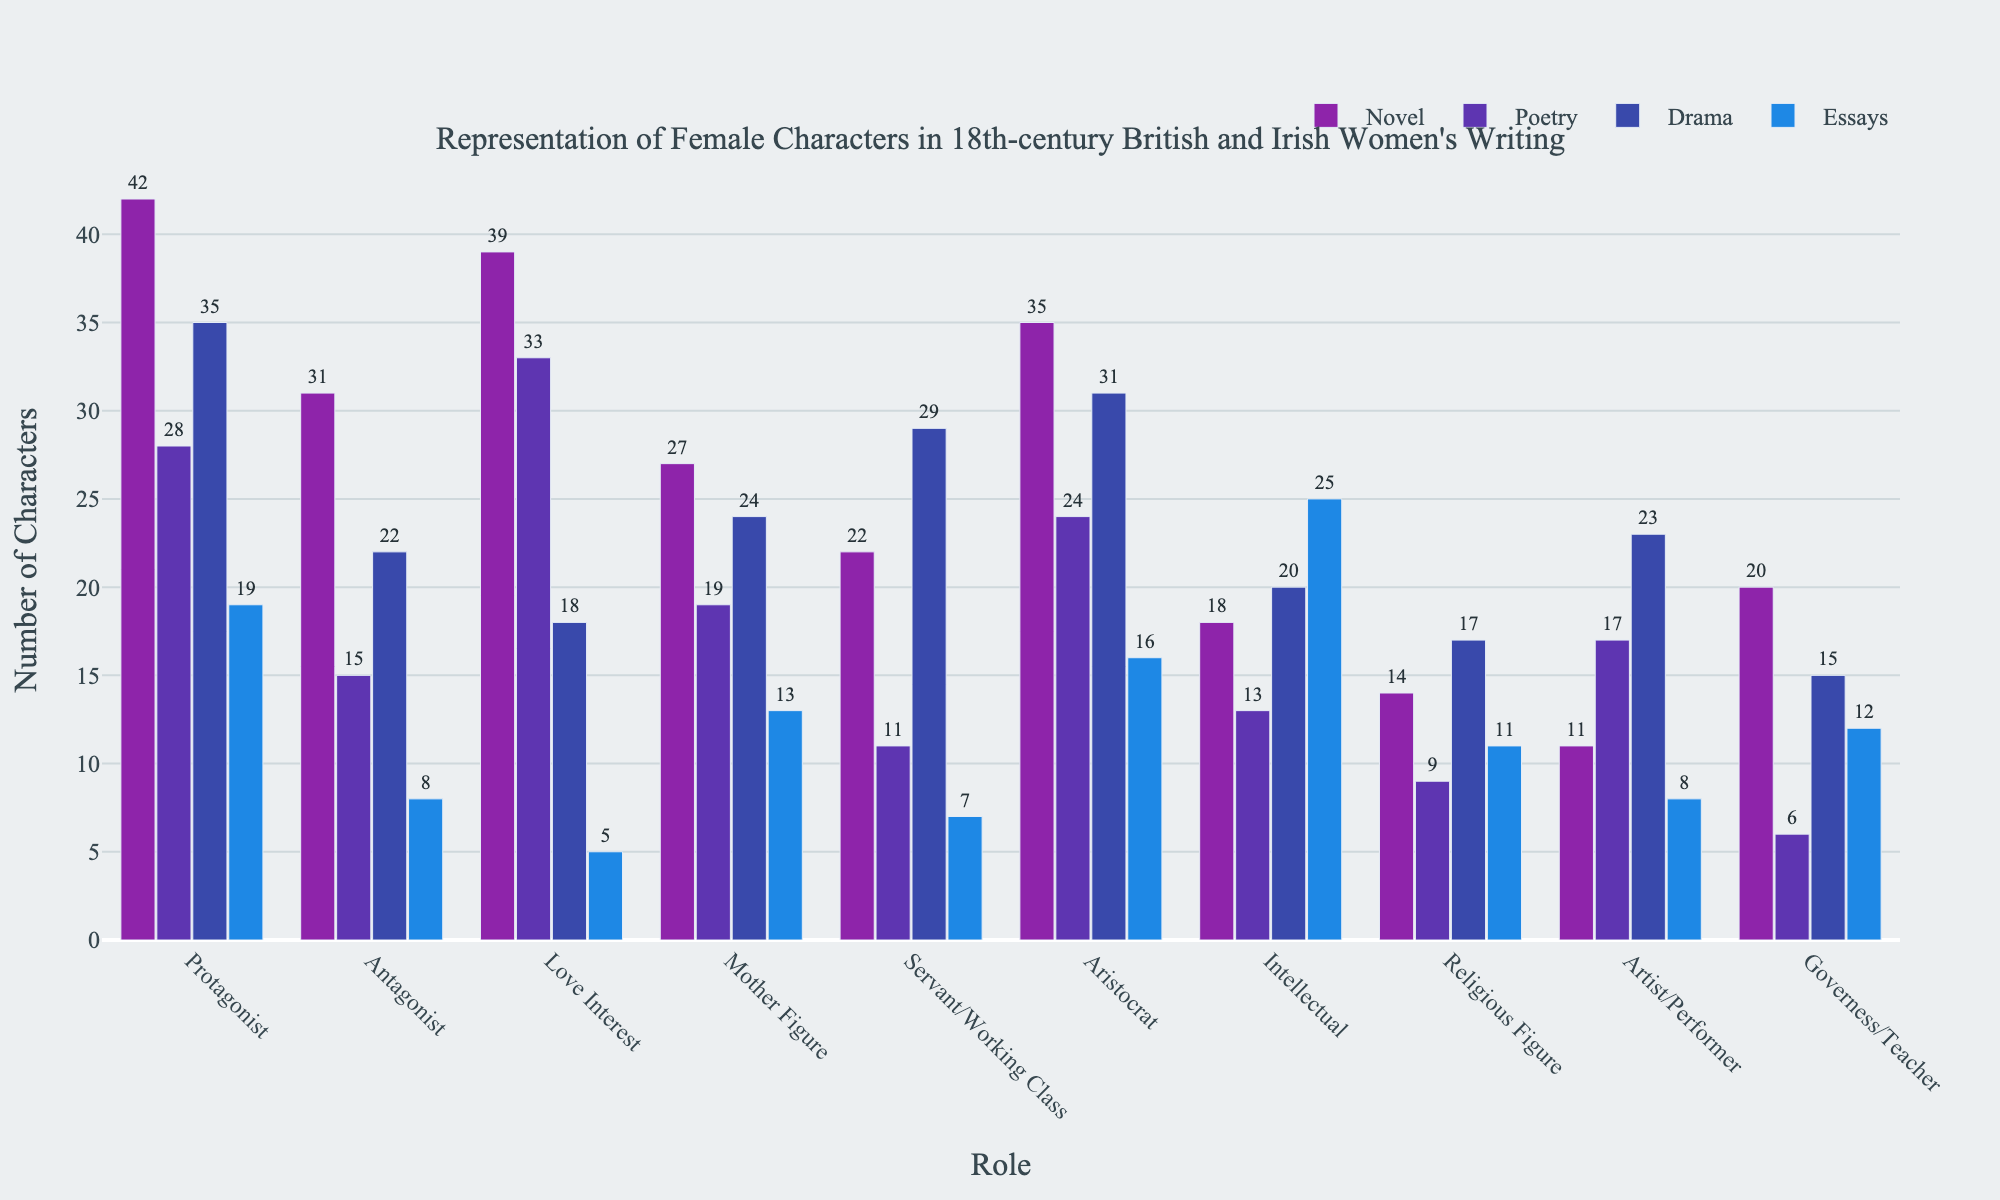Which literary form has the highest number of female protagonists? Look at the heights of the bars in the "Protagonist" category and compare them across different literary forms. The tallest bar indicates the highest number.
Answer: Novel How many female intellectuals are there in poetry and essays combined? Sum the number of female intellectuals in poetry (13) and essays (25) to get the total. 13 + 25 = 38
Answer: 38 Which role has the fewest female characters in novellas? Compare the heights of all bars within the "Novel" category and find the shortest one, which indicates the fewest characters.
Answer: Artist/Performer Is the number of female protagonists in drama greater than the number of female love interests in drama? Compare the number of female protagonists in drama (35) and love interests in drama (18). 35 is greater than 18.
Answer: Yes What is the average number of female characters in the "Mother Figure" role across all literary forms? Sum the number of female "Mother Figures" in all literary forms (27 + 19 + 24 + 13 = 83) and then divide by the number of literary forms (4). 83 / 4 = 20.75
Answer: 20.75 Do female characters in the role of "Servant/Working Class" appear more frequently in drama or novels? Compare the number of female "Servant/Working Class" characters in drama (29) and novels (22). 29 is greater than 22.
Answer: Drama Which role has the most similar number of female characters between essays and novels? Compare the heights of bars across the "Role" categories for essays and novels, and find the pair with the closest heights. In this case, "Governess/Teacher" in essays (12) and novels (20) have the smallest difference.
Answer: Governess/Teacher How many total female aristocrats are there across all literary forms? Sum the number of female aristocrats in all literary forms (35 + 24 + 31 + 16). 35 + 24 + 31 + 16 = 106
Answer: 106 Which role features the fewest female characters overall? Compare the total heights of the bars across all roles. The shortest total height indicates the fewest characters. "Artist/Performer" has the smallest total (11 + 17 + 23 + 8 = 59).
Answer: Artist/Performer 